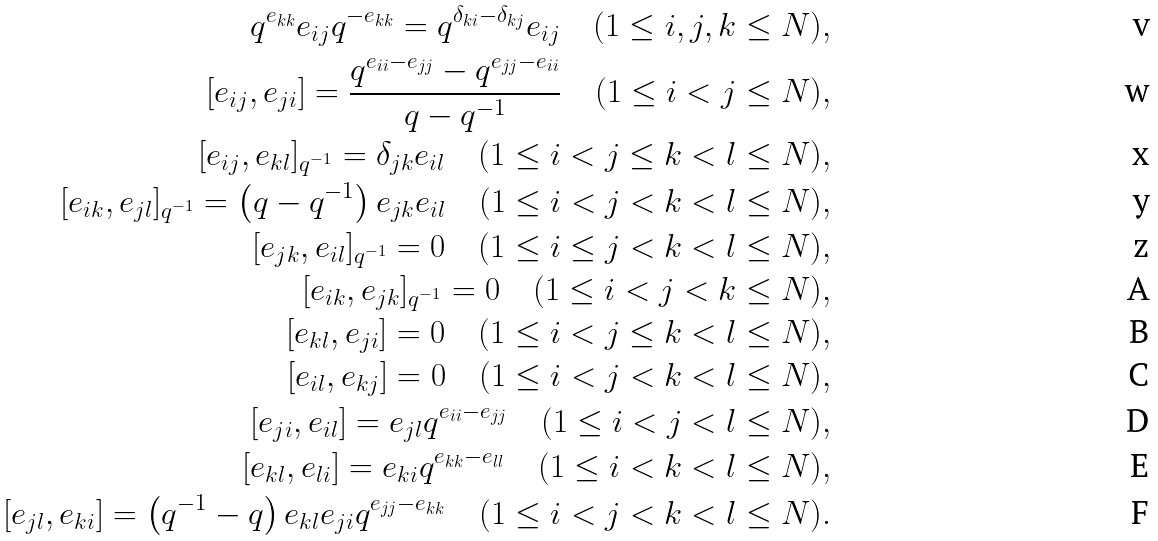Convert formula to latex. <formula><loc_0><loc_0><loc_500><loc_500>q ^ { e _ { k k } } e _ { i j } q ^ { - e _ { k k } } = q ^ { \delta _ { k i } - \delta _ { k j } } e _ { i j } \quad ( 1 \leq i , j , k \leq N ) , \\ [ e _ { i j } , e _ { j i } ] = \frac { q ^ { e _ { i i } - e _ { j j } } - q ^ { e _ { j j } - e _ { i i } } } { q - q ^ { - 1 } } \quad ( 1 \leq i < j \leq N ) , \\ [ e _ { i j } , e _ { k l } ] _ { q ^ { - 1 } } = \delta _ { j k } e _ { i l } \quad ( 1 \leq i < j \leq k < l \leq N ) , \\ [ e _ { i k } , e _ { j l } ] _ { q ^ { - 1 } } = \left ( q - q ^ { - 1 } \right ) e _ { j k } e _ { i l } \quad ( 1 \leq i < j < k < l \leq N ) , \\ [ e _ { j k } , e _ { i l } ] _ { q ^ { - 1 } } = 0 \quad ( 1 \leq i \leq j < k < l \leq N ) , \\ [ e _ { i k } , e _ { j k } ] _ { q ^ { - 1 } } = 0 \quad ( 1 \leq i < j < k \leq N ) , \\ [ e _ { k l } , e _ { j i } ] = 0 \quad ( 1 \leq i < j \leq k < l \leq N ) , \\ [ e _ { i l } , e _ { k j } ] = 0 \quad ( 1 \leq i < j < k < l \leq N ) , \\ [ e _ { j i } , e _ { i l } ] = e _ { j l } q ^ { e _ { i i } - e _ { j j } } \quad ( 1 \leq i < j < l \leq N ) , \\ [ e _ { k l } , e _ { l i } ] = e _ { k i } q ^ { e _ { k k } - e _ { l l } } \quad ( 1 \leq i < k < l \leq N ) , \\ [ e _ { j l } , e _ { k i } ] = \left ( q ^ { - 1 } - q \right ) e _ { k l } e _ { j i } q ^ { e _ { j j } - e _ { k k } } \quad ( 1 \leq i < j < k < l \leq N ) .</formula> 